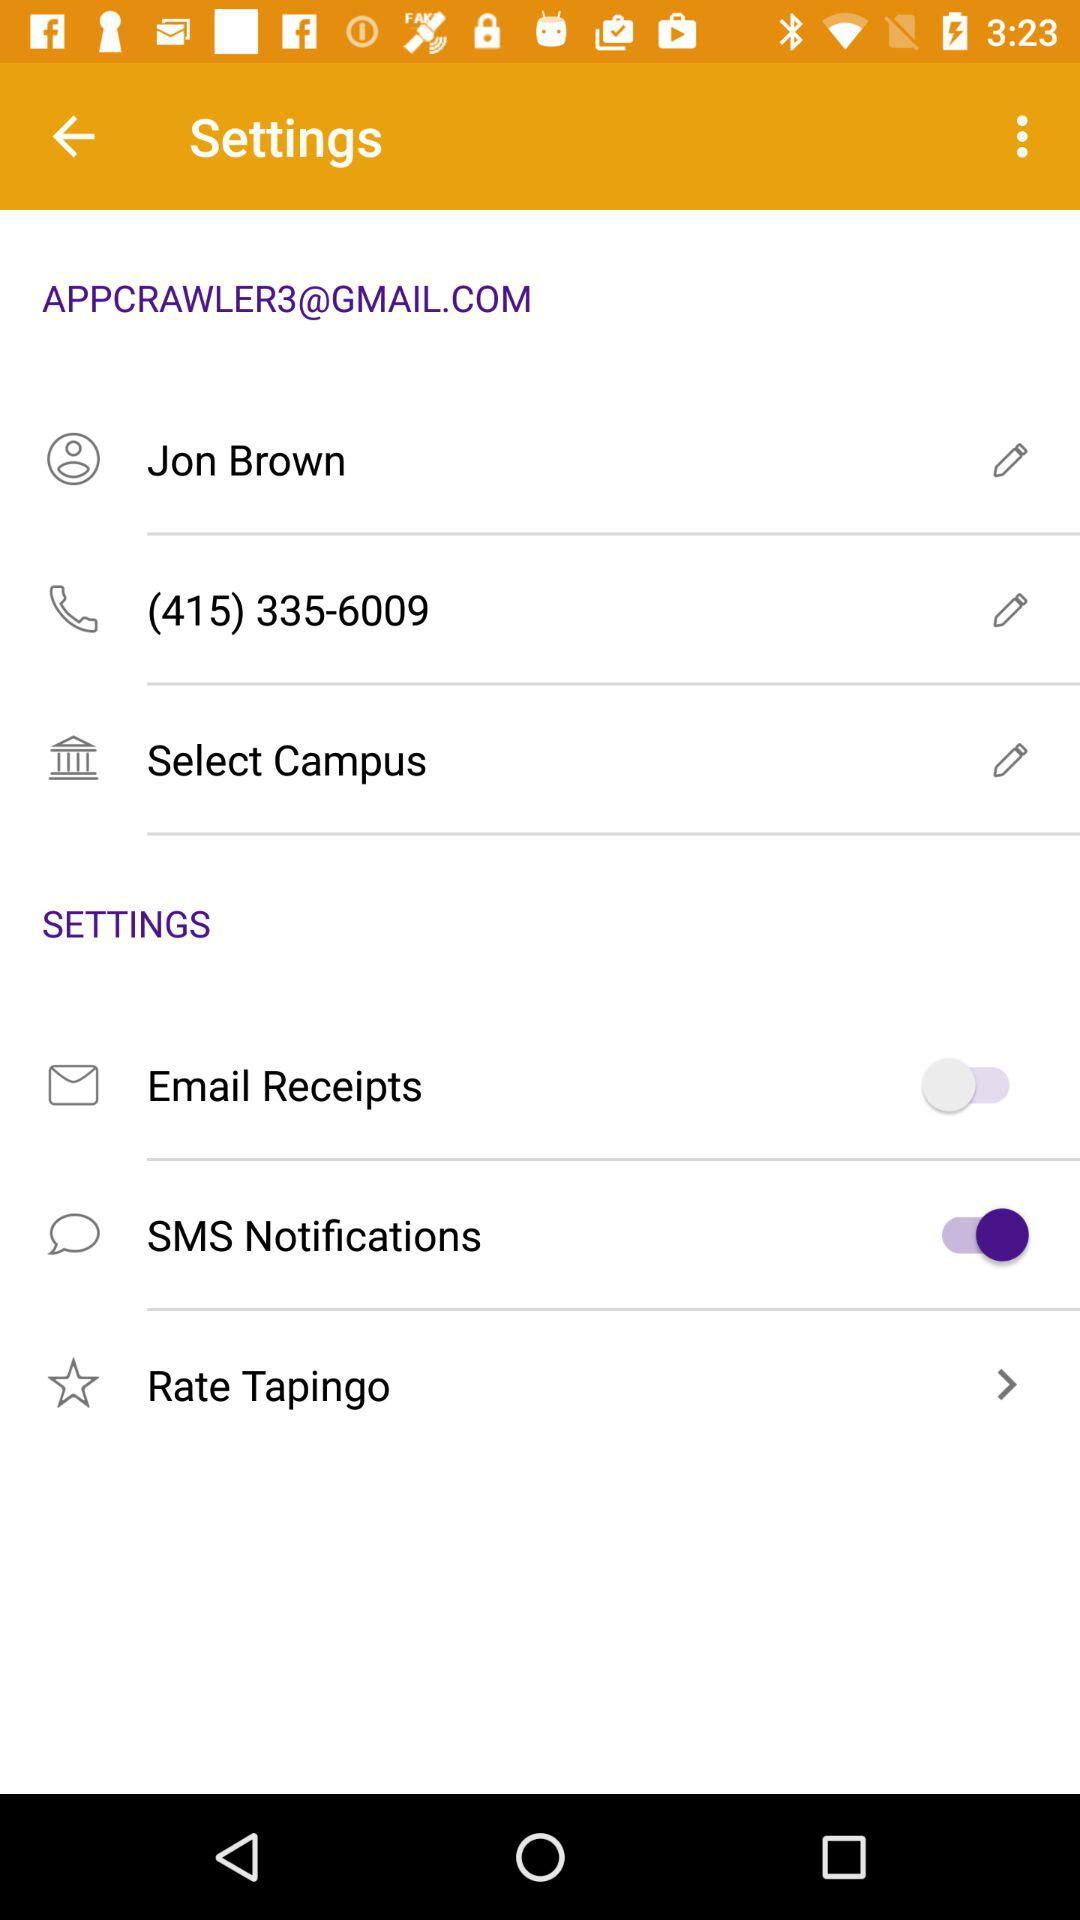What is the status of SMS notification? The status is "on". 